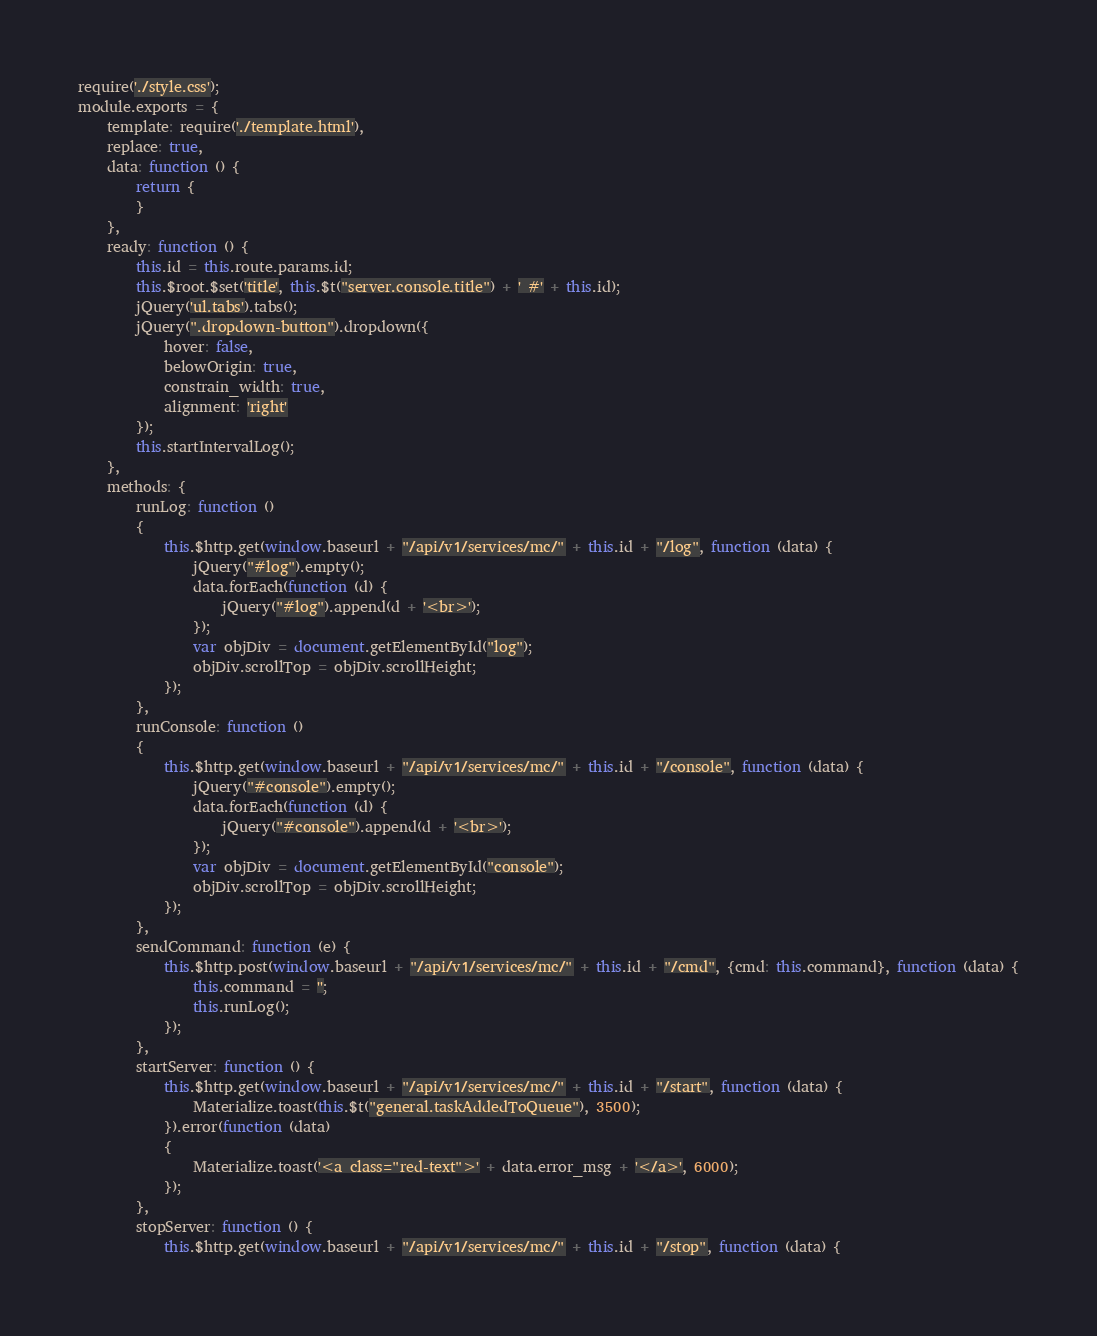<code> <loc_0><loc_0><loc_500><loc_500><_JavaScript_>require('./style.css');
module.exports = {
    template: require('./template.html'),
    replace: true,
    data: function () {
        return {
        }
    },
    ready: function () {
        this.id = this.route.params.id;
        this.$root.$set('title', this.$t("server.console.title") + ' #' + this.id);
        jQuery('ul.tabs').tabs();
        jQuery(".dropdown-button").dropdown({
            hover: false,
            belowOrigin: true,
            constrain_width: true,
            alignment: 'right'
        });
        this.startIntervalLog();
    },
    methods: {
        runLog: function ()
        {
            this.$http.get(window.baseurl + "/api/v1/services/mc/" + this.id + "/log", function (data) {
                jQuery("#log").empty();
                data.forEach(function (d) {
                    jQuery("#log").append(d + '<br>');
                });
                var objDiv = document.getElementById("log");
                objDiv.scrollTop = objDiv.scrollHeight;
            });
        },
        runConsole: function ()
        {
            this.$http.get(window.baseurl + "/api/v1/services/mc/" + this.id + "/console", function (data) {
                jQuery("#console").empty();
                data.forEach(function (d) {
                    jQuery("#console").append(d + '<br>');
                });
                var objDiv = document.getElementById("console");
                objDiv.scrollTop = objDiv.scrollHeight;
            });
        },
        sendCommand: function (e) {
            this.$http.post(window.baseurl + "/api/v1/services/mc/" + this.id + "/cmd", {cmd: this.command}, function (data) {
                this.command = '';
                this.runLog();
            });
        },
        startServer: function () {
            this.$http.get(window.baseurl + "/api/v1/services/mc/" + this.id + "/start", function (data) {
                Materialize.toast(this.$t("general.taskAddedToQueue"), 3500);
            }).error(function (data)
            {
                Materialize.toast('<a class="red-text">' + data.error_msg + '</a>', 6000);
            });
        },
        stopServer: function () {
            this.$http.get(window.baseurl + "/api/v1/services/mc/" + this.id + "/stop", function (data) {</code> 